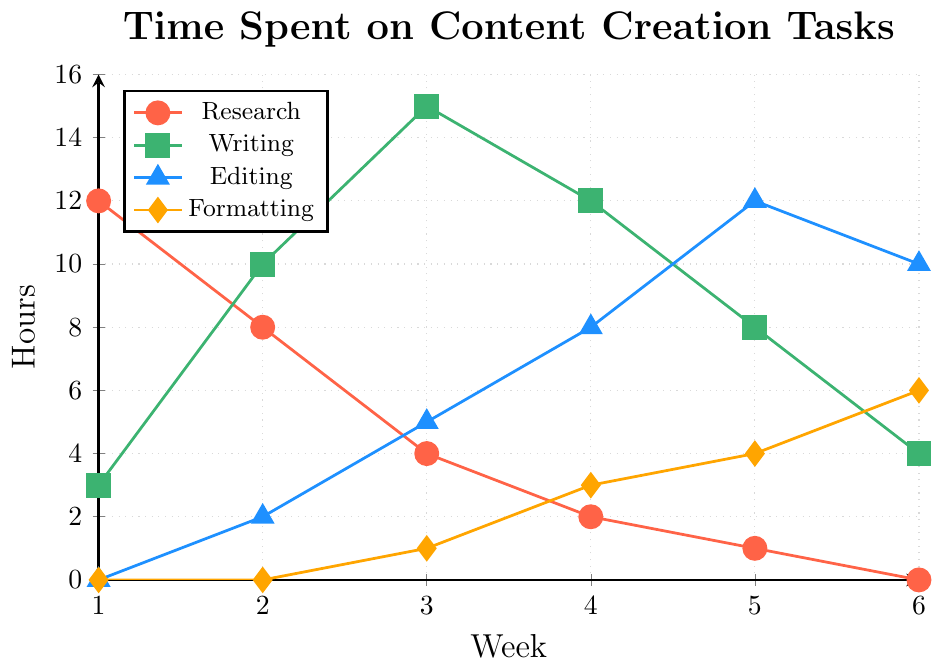How many hours were spent on research in Week 1 and Week 6 combined? To find the total hours spent on research in Week 1 and Week 6, add the values for Week 1 (12 hours) and Week 6 (0 hours). 12 + 0 = 12.
Answer: 12 Which task had the highest total time spent over the 6 weeks? Sum the hours spent on each task over the 6 weeks and compare them. Research: 12 + 8 + 4 + 2 + 1 + 0 = 27, Writing: 3 + 10 + 15 + 12 + 8 + 4 = 52, Editing: 0 + 2 + 5 + 8 + 12 + 10 = 37, Formatting: 0 + 0 + 1 + 3 + 4 + 6 = 14. Writing has the highest total time spent.
Answer: Writing What was the trend in hours spent on formatting from Week 1 to Week 6? Observe the pattern of hours spent on formatting over the weeks. Week 1: 0, Week 2: 0, Week 3: 1, Week 4: 3, Week 5: 4, Week 6: 6. The hours increased gradually over the weeks.
Answer: Increased How did the hours spent on editing compare between Week 2 and Week 5? Check the hours spent on editing in Week 2 and Week 5. Week 2: 2 hours, Week 5: 12 hours. Week 5 had more hours spent on editing compared to Week 2.
Answer: Week 5 had more hours Which week had the highest total time spent across all tasks combined? Calculate the total time spent across all tasks for each week. Week 1: 15, Week 2: 20, Week 3: 25, Week 4: 25, Week 5: 25, Week 6: 20. Week 3, Week 4, and Week 5 had the highest total time spent (25 hours each).
Answer: Week 3, Week 4, Week 5 What was the average time spent on writing during Week 2 and Week 3? Find the average by adding the hours spent on writing in Week 2 and Week 3, then divide by 2. Writing in Week 2: 10, Week 3: 15. (10 + 15) / 2 = 12.5.
Answer: 12.5 Between which weeks did the hours spent on editing increase the most? Look for the largest increase in editing hours between consecutive weeks by comparing the difference in hours. Week 1 to Week 2: 2, Week 2 to Week 3: 3, Week 3 to Week 4: 3, Week 4 to Week 5: 4, Week 5 to Week 6: -2. The largest increase was between Week 4 and Week 5.
Answer: Week 4 and Week 5 